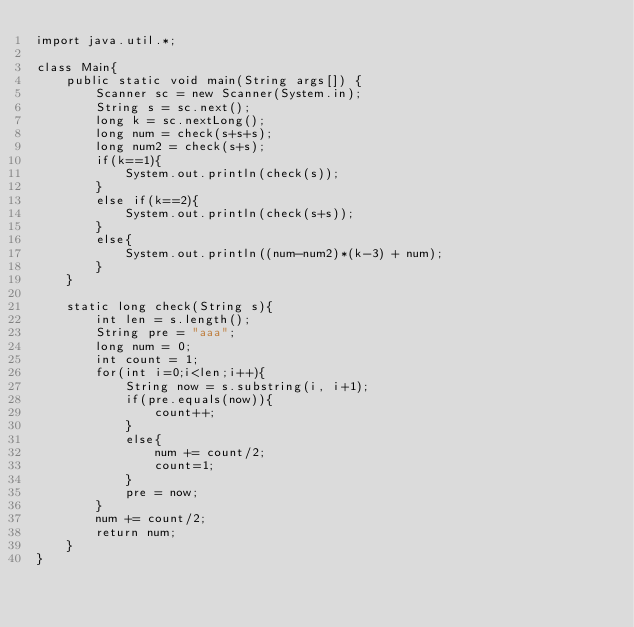Convert code to text. <code><loc_0><loc_0><loc_500><loc_500><_Java_>import java.util.*;

class Main{
    public static void main(String args[]) {
        Scanner sc = new Scanner(System.in);
        String s = sc.next();
        long k = sc.nextLong();
        long num = check(s+s+s);
        long num2 = check(s+s);
        if(k==1){
            System.out.println(check(s));
        }
        else if(k==2){
            System.out.println(check(s+s));
        }
        else{
            System.out.println((num-num2)*(k-3) + num);
        }
    }

    static long check(String s){
        int len = s.length();
        String pre = "aaa";
        long num = 0;
        int count = 1;
        for(int i=0;i<len;i++){
            String now = s.substring(i, i+1);
            if(pre.equals(now)){
                count++;
            }
            else{
                num += count/2;
                count=1;
            }
            pre = now;
        }
        num += count/2;
        return num;
    }
}
</code> 